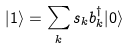<formula> <loc_0><loc_0><loc_500><loc_500>| 1 \rangle = \sum _ { k } s _ { k } b _ { k } ^ { \dagger } | 0 \rangle</formula> 